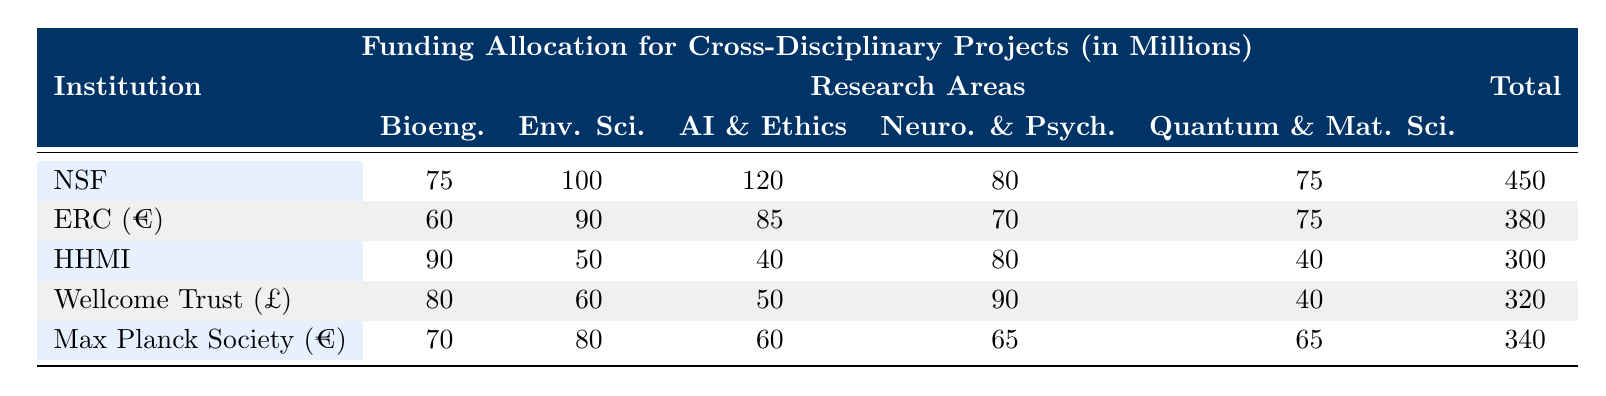What is the total funding allocated by the National Science Foundation? The total funding for the National Science Foundation is listed in the "Total" column, which shows $450 million.
Answer: $450 million Which institution has the highest funding for Artificial Intelligence & Ethics? By comparing the values in the Artificial Intelligence & Ethics column, the National Science Foundation has the highest funding at $120 million, more than the others.
Answer: National Science Foundation What is the difference in funding for Quantum Computing & Materials Science between HHMI and Wellcome Trust? The funding for Quantum Computing & Materials Science at HHMI is $40 million and for Wellcome Trust, it is £40 million. Since both values are equal, the difference is $0 million.
Answer: $0 million Is the funding for Bioengineering at the Max Planck Society greater than that of the European Research Council? The funding for Bioengineering at Max Planck Society is €70 million, while for the European Research Council it is €60 million. Thus, it is true that the Max Planck Society has greater funding.
Answer: Yes What is the average funding allocation for Neuroscience & Psychology across all institutions? To calculate the average, sum the values for Neuroscience & Psychology: 80 (NSF) + 70 (ERC) + 80 (HHMI) + 90 (Wellcome Trust) + 65 (Max Planck) = 385. Then divide by 5 to find the average: 385 / 5 = 77.
Answer: 77 million Which institution received less than $100 million for Environmental Science & Sustainability? The only institutions with less than $100 million for Environmental Science & Sustainability are HHMI ($50 million) and Wellcome Trust (£60 million). Therefore, both these institutions meet the criteria.
Answer: HHMI, Wellcome Trust What is the total amount funded for all categories by the European Research Council? The total funding for ERC is provided directly in the "Total" column as €380 million; no calculation is necessary beyond this direct retrieval.
Answer: €380 million How much more funding does the Wellcome Trust have for Neuroscience & Psychology compared to HHMI? The funding for Neuroscience & Psychology is £90 million at Wellcome Trust and $80 million at HHMI. The difference is £90 million - $80 million = £10 million.
Answer: £10 million Which two institutions have the closest total funding amounts? Assessing the total funding amounts, the National Science Foundation is $450 million and the Max Planck Society is €340 million. The closest totals relative to the others are ERC (€380 million) and Max Planck Society; their amounts are nearest to one another compared to other institutions.
Answer: ERC and Max Planck Society 